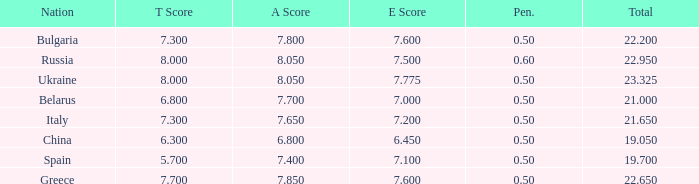Could you parse the entire table as a dict? {'header': ['Nation', 'T Score', 'A Score', 'E Score', 'Pen.', 'Total'], 'rows': [['Bulgaria', '7.300', '7.800', '7.600', '0.50', '22.200'], ['Russia', '8.000', '8.050', '7.500', '0.60', '22.950'], ['Ukraine', '8.000', '8.050', '7.775', '0.50', '23.325'], ['Belarus', '6.800', '7.700', '7.000', '0.50', '21.000'], ['Italy', '7.300', '7.650', '7.200', '0.50', '21.650'], ['China', '6.300', '6.800', '6.450', '0.50', '19.050'], ['Spain', '5.700', '7.400', '7.100', '0.50', '19.700'], ['Greece', '7.700', '7.850', '7.600', '0.50', '22.650']]} What's the sum of A Score that also has a score lower than 7.3 and an E Score larger than 7.1? None. 